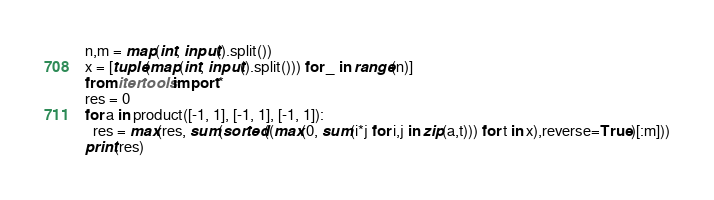Convert code to text. <code><loc_0><loc_0><loc_500><loc_500><_Python_>n,m = map(int, input().split())
x = [tuple(map(int, input().split())) for _ in range(n)]
from itertools import *
res = 0
for a in product([-1, 1], [-1, 1], [-1, 1]):
  res = max(res, sum(sorted((max(0, sum(i*j for i,j in zip(a,t))) for t in x),reverse=True)[:m]))
print(res)</code> 